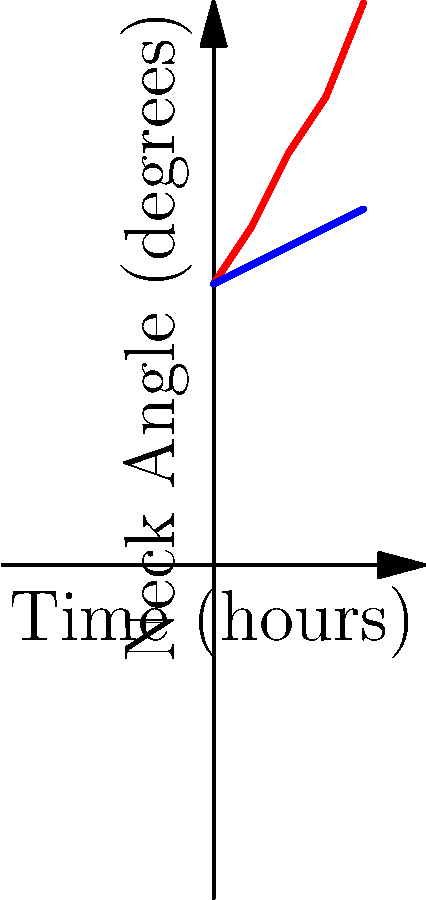The graph shows the neck angle of cashiers over an 8-hour shift using two different cash register setups. Based on the data, which setup is more ergonomic, and what is the approximate difference in neck angle between the two setups at the end of the shift? To determine which setup is more ergonomic and calculate the difference in neck angle:

1. Identify the two setups:
   - Red line: Traditional Setup
   - Blue line: Ergonomic Setup

2. Compare the trends:
   - Traditional Setup: Neck angle increases significantly over time
   - Ergonomic Setup: Neck angle increases slightly over time

3. Analyze ergonomics:
   - Lower neck angles are generally better for posture
   - The Ergonomic Setup maintains a lower neck angle throughout the shift

4. Calculate the difference at the end of the shift (8 hours):
   - Traditional Setup neck angle at 8 hours: $30°$
   - Ergonomic Setup neck angle at 8 hours: $19°$
   - Difference: $30° - 19° = 11°$

5. Conclusion:
   - The Ergonomic Setup is more ergonomic due to lower neck angles
   - The approximate difference in neck angle at the end of the shift is $11°$
Answer: Ergonomic Setup; 11° 